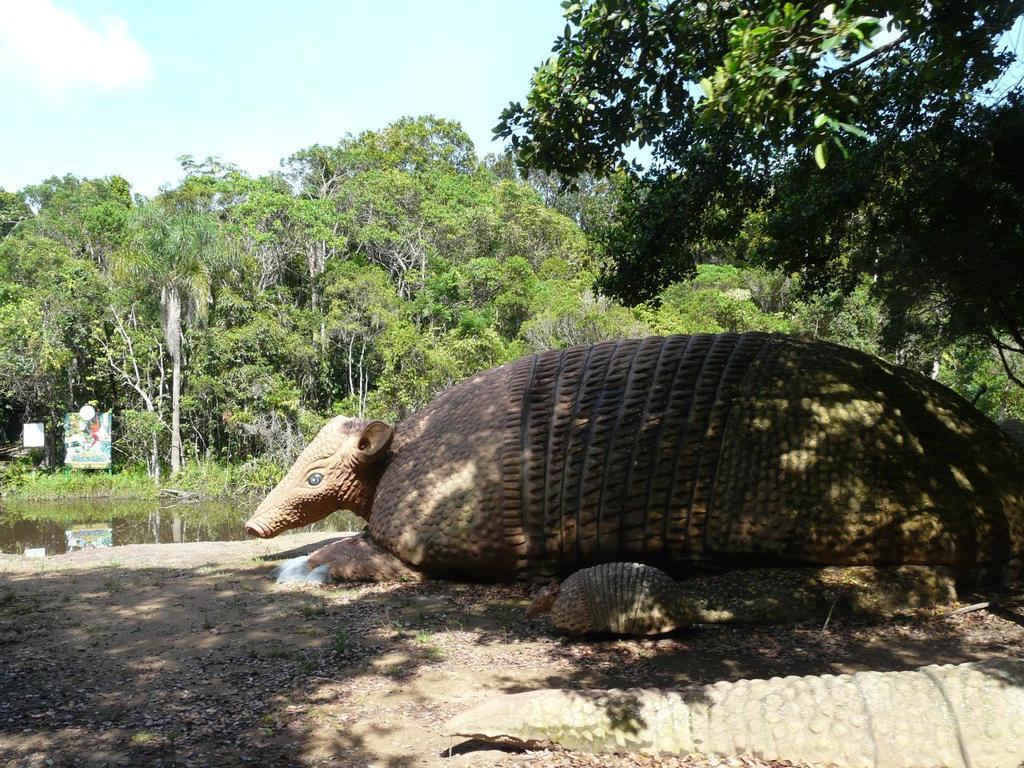In one or two sentences, can you explain what this image depicts? At the bottom of the picture, we see the tail of the crocodile. Beside that, we see an animal. It might be a statue. Behind that, we see water in the pond. In the background, we see a board. There are trees in the background. At the top of the picture, we see the sky. This picture might be clicked in a zoo. 